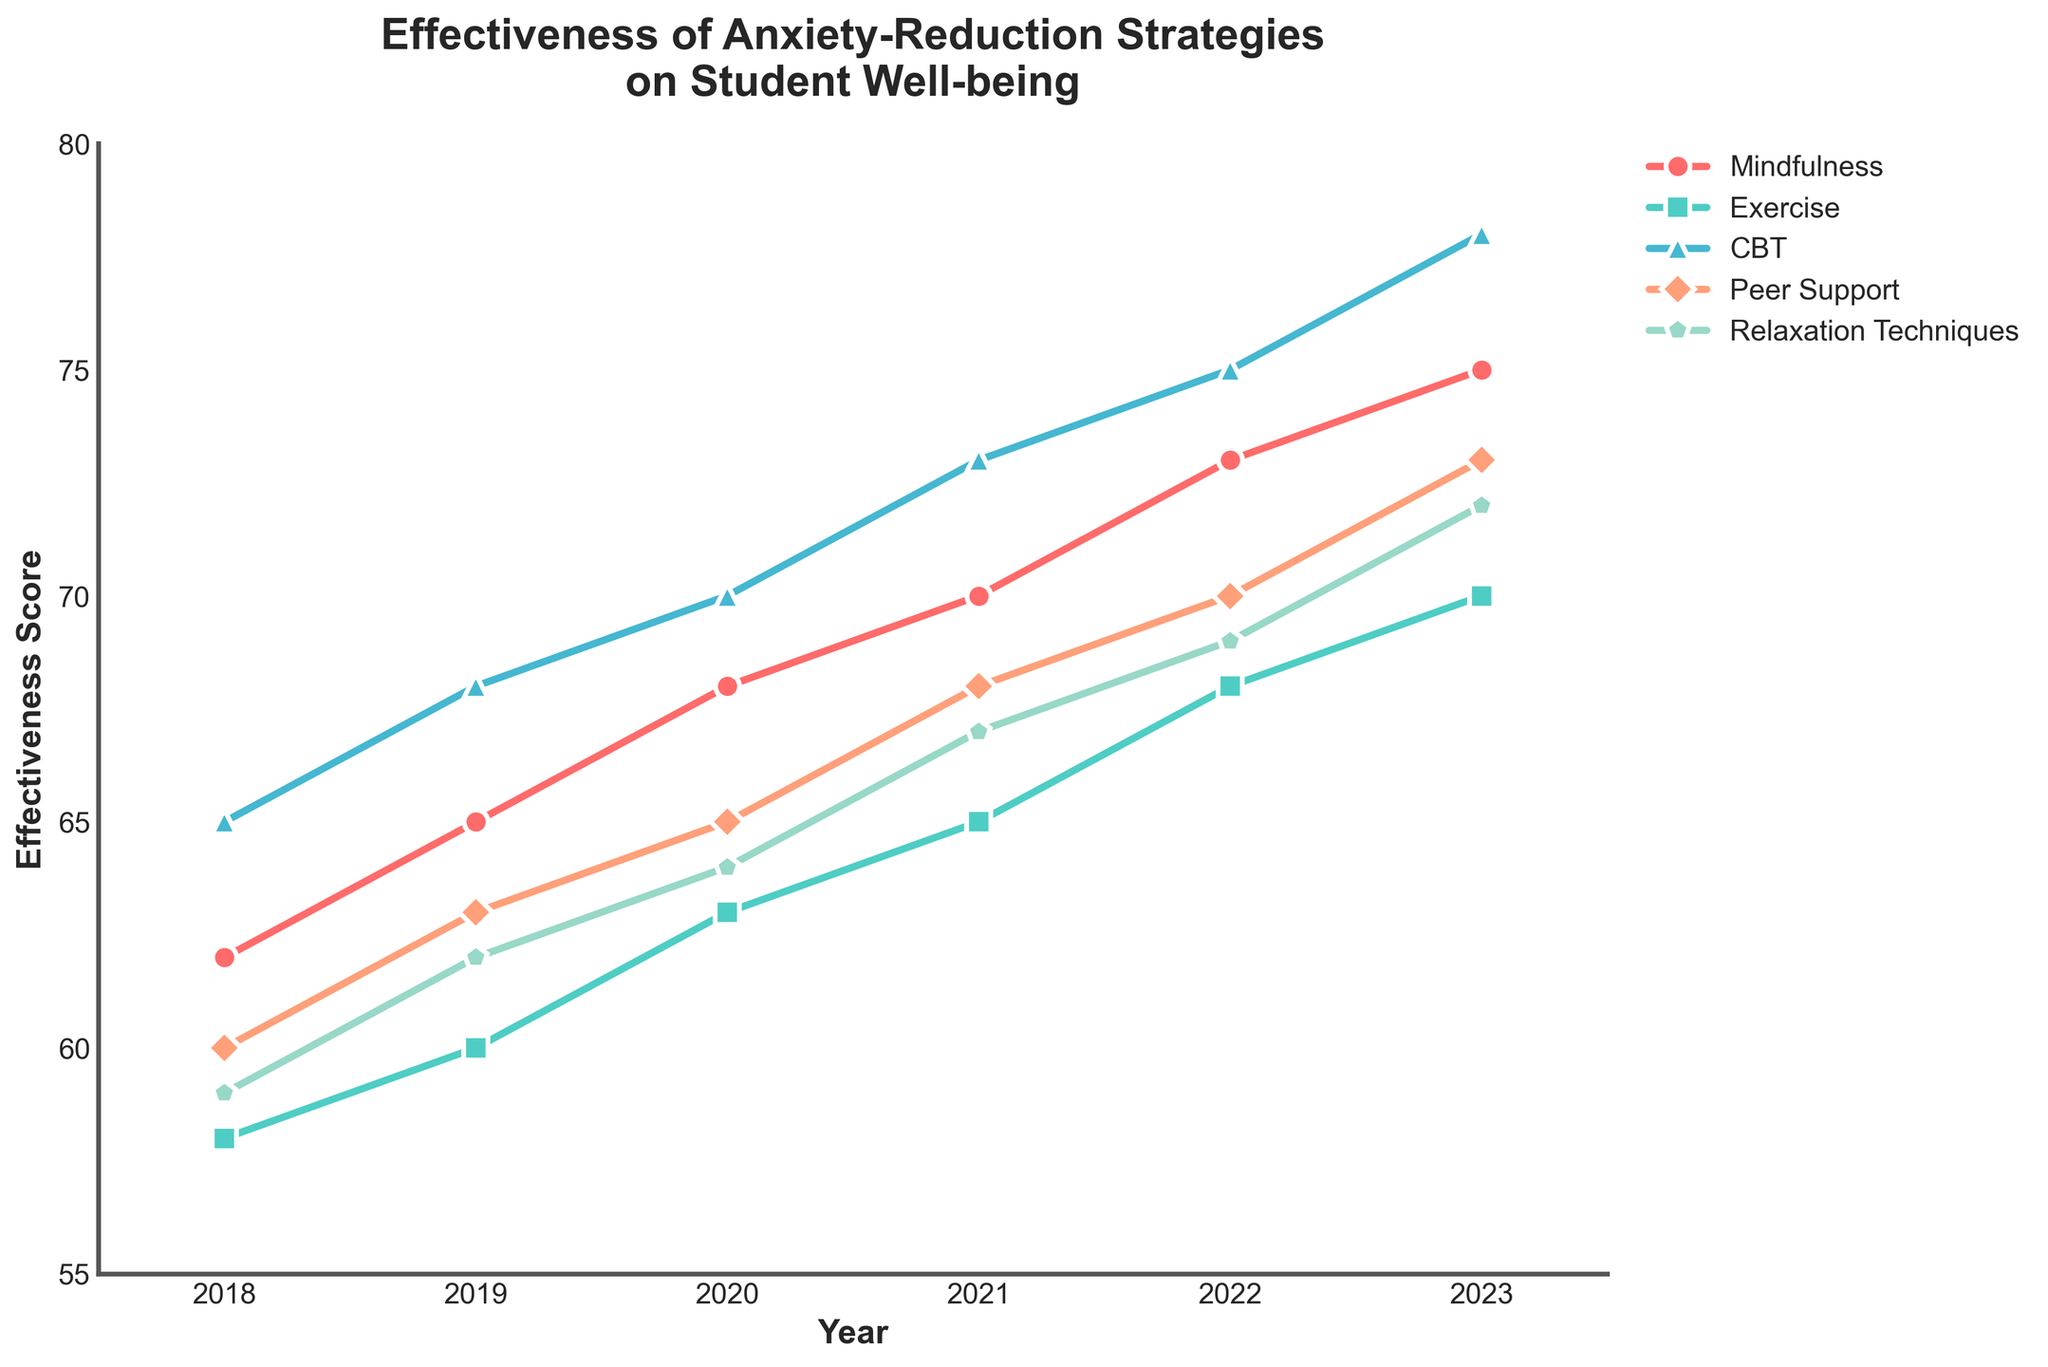Which year had the highest effectiveness score for CBT? To find the highest effectiveness score for CBT, we look at the CBT data across all years and identify that 2023 has the highest score, which is 78.
Answer: 2023 What is the effectiveness difference between Mindfulness and Exercise in 2020? For 2020, the effectiveness score for Mindfulness is 68 and for Exercise is 63. The difference is 68 - 63 = 5.
Answer: 5 Which strategy showed the most improvement from 2018 to 2023? Calculate the increase for each strategy from 2018 to 2023. Mindfulness: (75-62)=13, Exercise: (70-58)=12, CBT: (78-65)=13, Peer Support: (73-60)=13, Relaxation Techniques: (72-59)=13. Multiple strategies (Mindfulness, CBT, Peer Support, and Relaxation Techniques) each improved by 13 points.
Answer: Multiple strategies (Mindfulness, CBT, Peer Support, Relaxation Techniques) Compare the effectiveness scores of Peer Support and Relaxation Techniques in 2021. Which is higher? For 2021, Peer Support has an effectiveness score of 68, while Relaxation Techniques have a score of 67. Therefore, Peer Support is higher by 1 point.
Answer: Peer Support What is the average effectiveness score of Exercise from 2018 to 2023? Sum the effectiveness scores of Exercise from each year: (58 + 60 + 63 + 65 + 68 + 70) = 384. Then divide by the number of years (6). 384 / 6 = 64.
Answer: 64 In which year did Mindfulness have an effectiveness score exceeding 70? Mindfulness scores exceed 70 in the years 2021, 2022, and 2023.
Answer: 2021, 2022, 2023 Which strategy had the least effectiveness score in any year? What was the score? Reviewing all years and strategies, the lowest score is for Exercise in 2018, which is 58.
Answer: Exercise, 58 